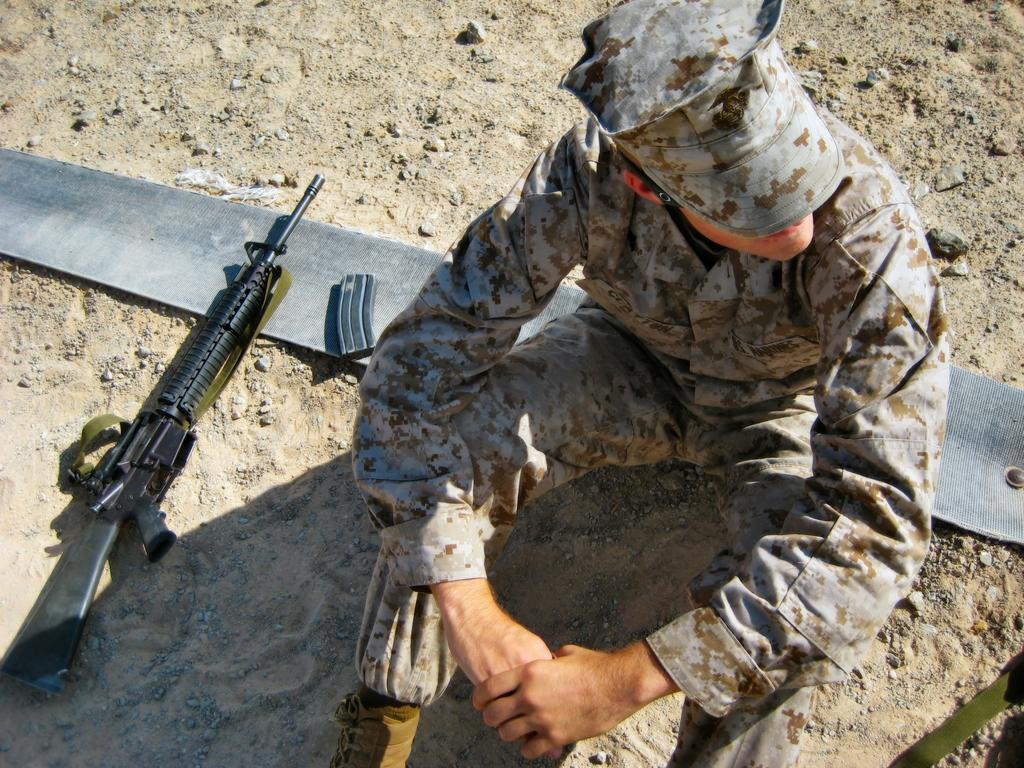Who is present in the image? There is a person in the image. What is the person wearing? The person is wearing a uniform. What is the person's position in the image? The person is sitting on the ground. What objects are beside the person? There is a gun and another object beside the person. What is the temperature of the sea in the image? There is no sea present in the image, so it is not possible to determine the temperature of the water. 